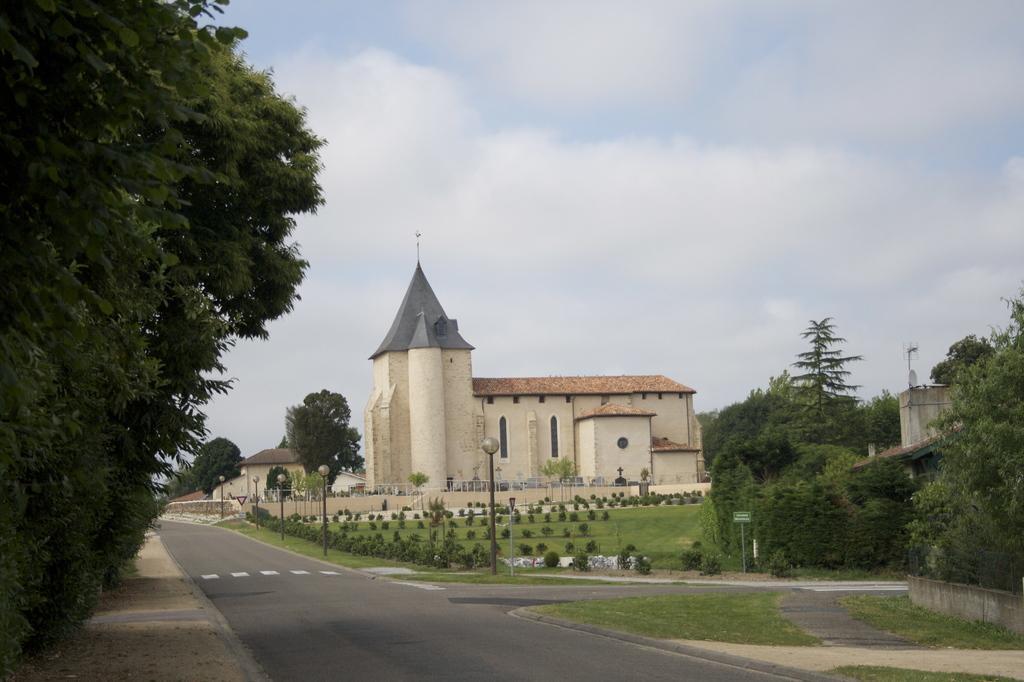Could you give a brief overview of what you see in this image? In this image we can see houses, plants, trees, light poles, a board, also we can see the sky. 